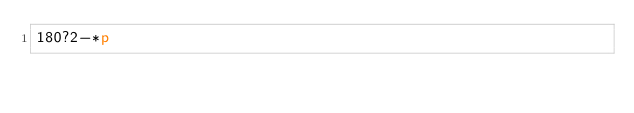<code> <loc_0><loc_0><loc_500><loc_500><_dc_>180?2-*p</code> 